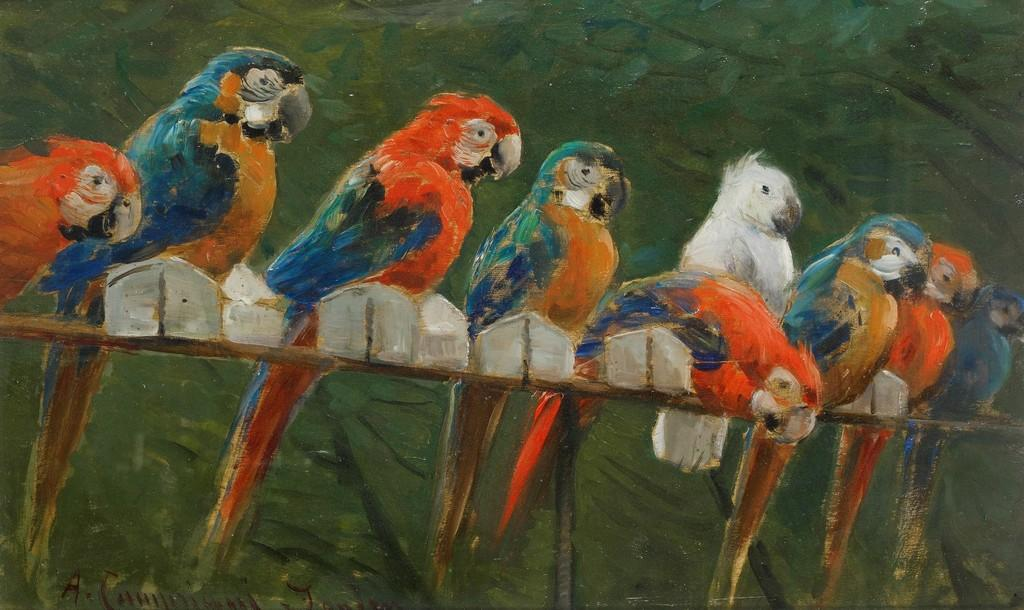What is the main subject of the painting in the image? The main subject of the painting in the image is parrots. How are the parrots positioned in the painting? The parrots are depicted on a wooden branch in the painting. What type of environment is shown in the painting? There are trees in the painting, suggesting a natural setting. Is there any text present in the image? Yes, there is some text in the bottom left corner of the image. What type of bottle can be seen in the painting? There is no bottle present in the painting; it features parrots on a wooden branch and trees in the background. How does the artist control the parrots in the painting? The artist does not control the parrots in the painting; they are depicted as part of the artwork. 